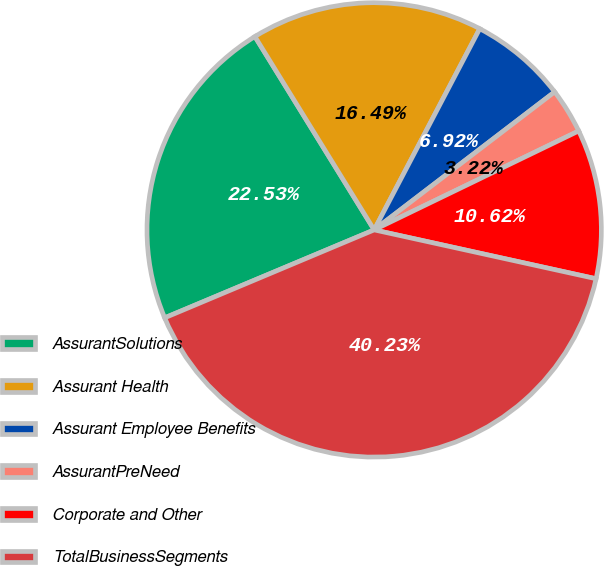Convert chart. <chart><loc_0><loc_0><loc_500><loc_500><pie_chart><fcel>AssurantSolutions<fcel>Assurant Health<fcel>Assurant Employee Benefits<fcel>AssurantPreNeed<fcel>Corporate and Other<fcel>TotalBusinessSegments<nl><fcel>22.53%<fcel>16.49%<fcel>6.92%<fcel>3.22%<fcel>10.62%<fcel>40.23%<nl></chart> 